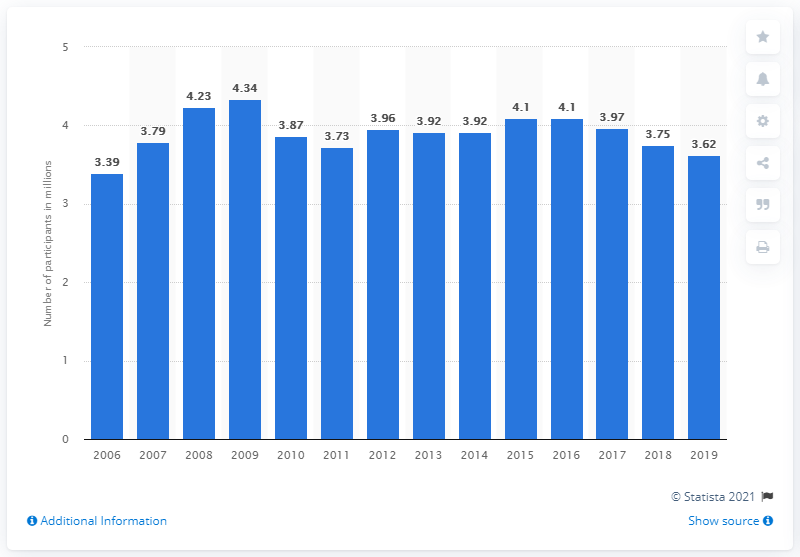Specify some key components in this picture. In 2019, a total of 3.62 people were sailing in the United States. Approximately 3.75 million people participated in sailing in the United States in the previous year. 